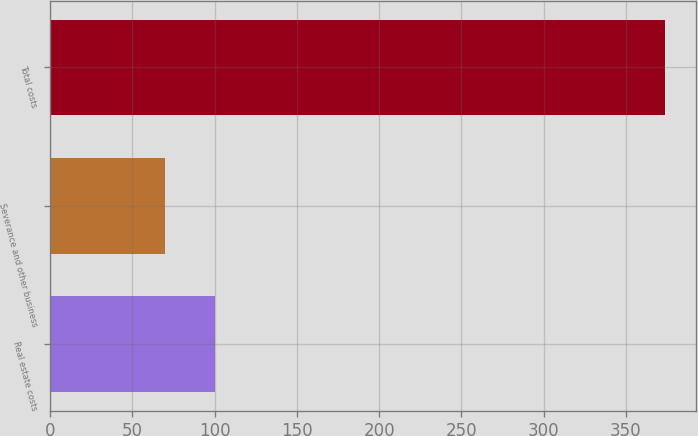Convert chart. <chart><loc_0><loc_0><loc_500><loc_500><bar_chart><fcel>Real estate costs<fcel>Severance and other business<fcel>Total costs<nl><fcel>100.4<fcel>70<fcel>374<nl></chart> 